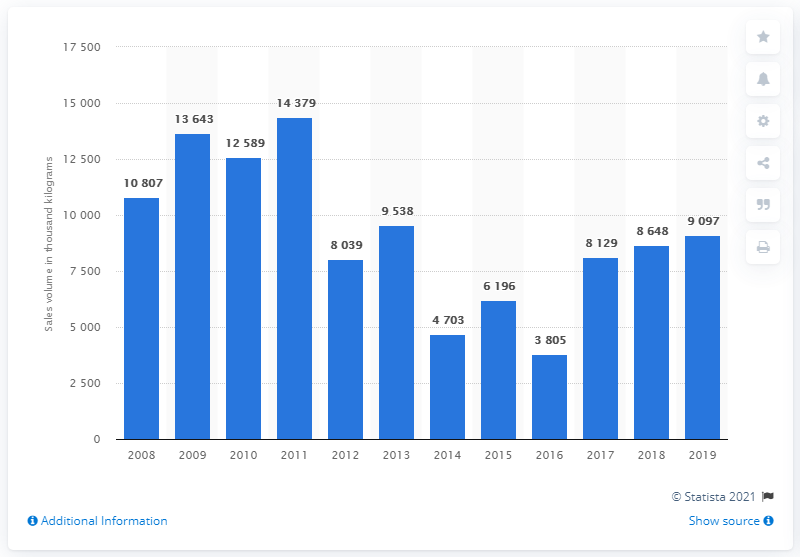Point out several critical features in this image. In 2019, the sales volume of sugar confectionery was approximately 9,097 units. 